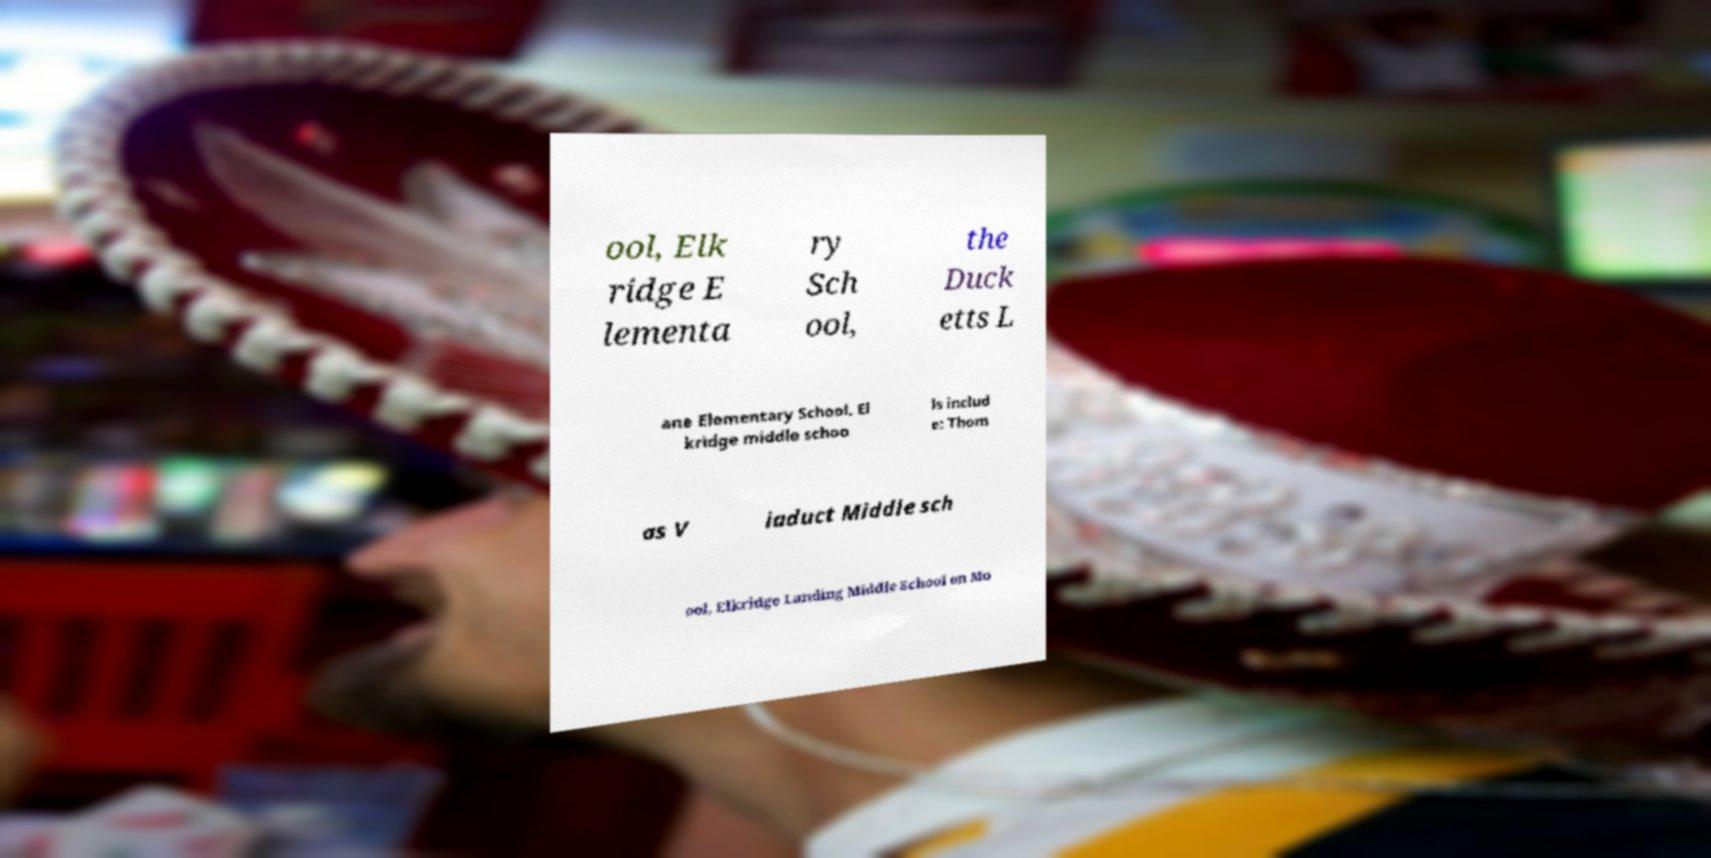Please read and relay the text visible in this image. What does it say? ool, Elk ridge E lementa ry Sch ool, the Duck etts L ane Elementary School. El kridge middle schoo ls includ e: Thom as V iaduct Middle sch ool, Elkridge Landing Middle School on Mo 